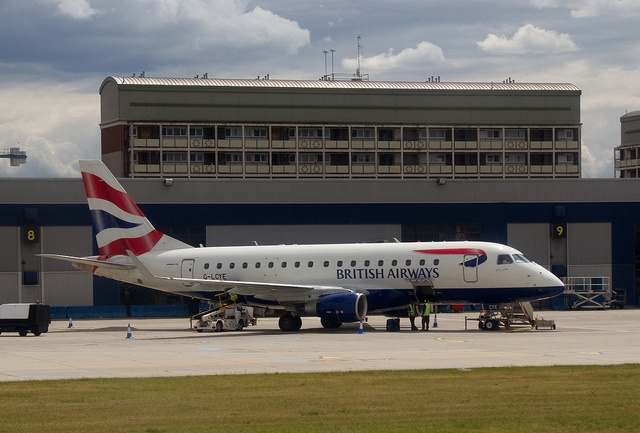Describe the objects in this image and their specific colors. I can see airplane in gray, darkgray, black, and lightgray tones, truck in gray, black, and darkgray tones, truck in gray and black tones, people in gray, black, olive, and darkgray tones, and suitcase in gray, black, and darkgray tones in this image. 